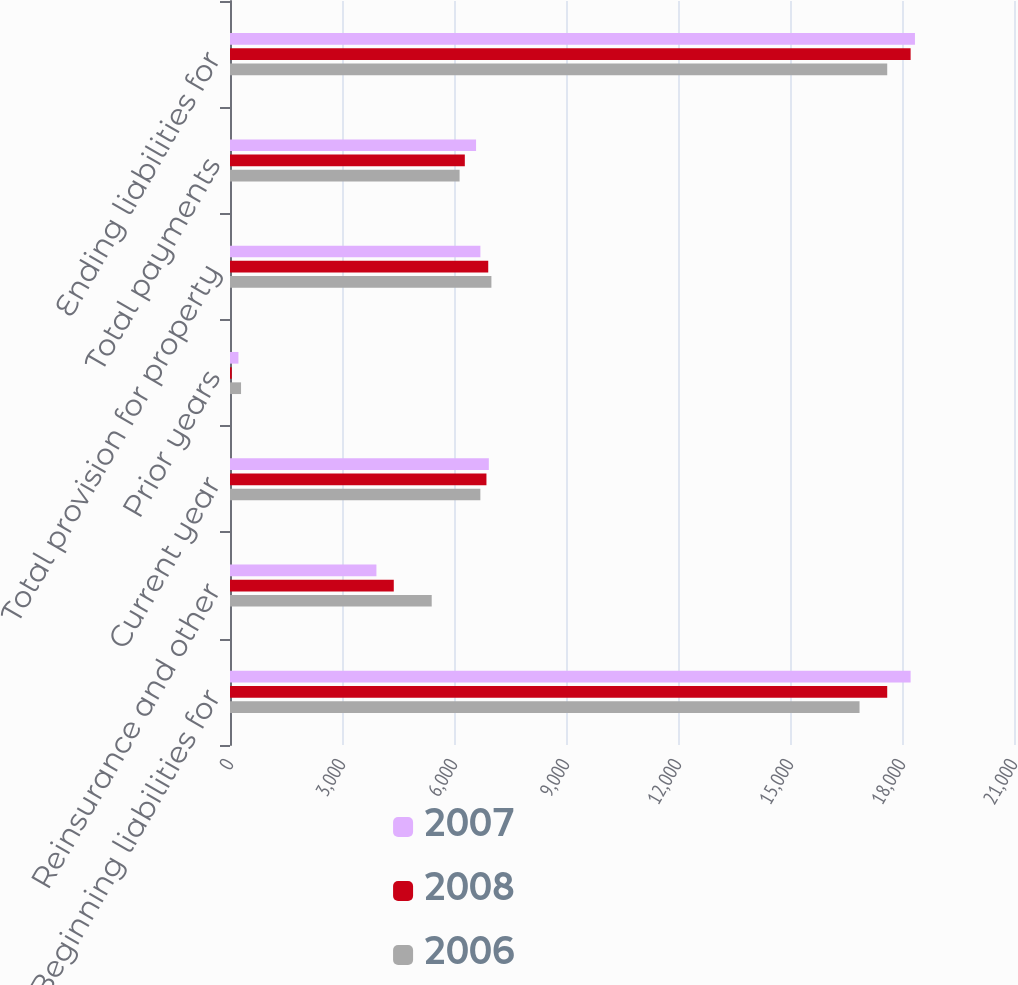<chart> <loc_0><loc_0><loc_500><loc_500><stacked_bar_chart><ecel><fcel>Beginning liabilities for<fcel>Reinsurance and other<fcel>Current year<fcel>Prior years<fcel>Total provision for property<fcel>Total payments<fcel>Ending liabilities for<nl><fcel>2007<fcel>18231<fcel>3922<fcel>6933<fcel>226<fcel>6707<fcel>6591<fcel>18347<nl><fcel>2008<fcel>17604<fcel>4387<fcel>6869<fcel>48<fcel>6917<fcel>6290<fcel>18231<nl><fcel>2006<fcel>16863<fcel>5403<fcel>6706<fcel>296<fcel>7002<fcel>6150<fcel>17604<nl></chart> 